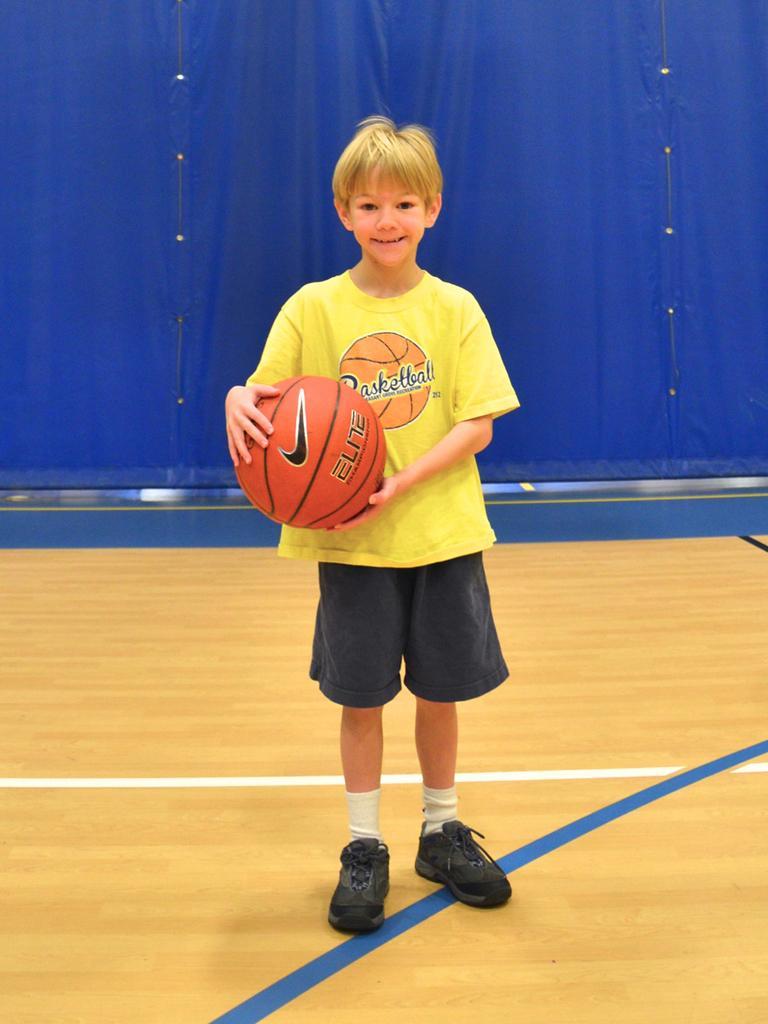Please provide a concise description of this image. Here is a boy who is in yellow color tee shirt and black shorts is holding a ball in his hand and the back curtain is blue in color. 